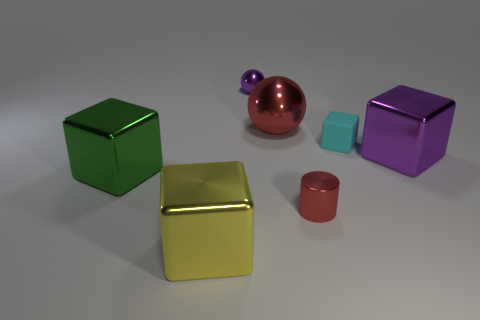Are there more large purple metallic blocks than big metallic things?
Your answer should be very brief. No. What number of large purple blocks are the same material as the small cyan object?
Your answer should be compact. 0. Is the shape of the matte object the same as the big green shiny thing?
Your answer should be very brief. Yes. What is the size of the green metal object that is on the left side of the cube in front of the shiny cube on the left side of the yellow cube?
Your response must be concise. Large. Are there any big purple shiny cubes to the right of the metallic object that is to the right of the cyan thing?
Offer a terse response. No. What number of metal objects are in front of the purple object to the left of the red object that is in front of the cyan cube?
Make the answer very short. 5. The large shiny object that is both to the right of the yellow cube and on the left side of the shiny cylinder is what color?
Offer a very short reply. Red. What number of small rubber things are the same color as the large sphere?
Give a very brief answer. 0. What number of balls are either small red objects or big purple objects?
Give a very brief answer. 0. There is a cylinder that is the same size as the rubber object; what color is it?
Your response must be concise. Red. 